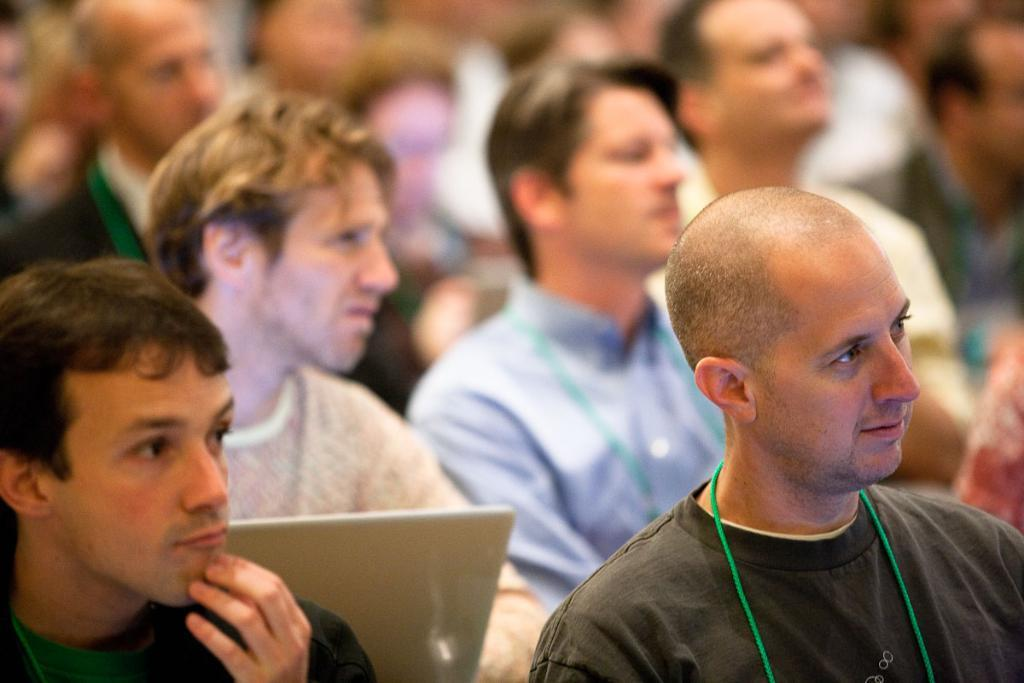What is the main subject of the image? The main subject of the image is a group of men. What are the men in the image doing? The men are looking to the right side. Can you describe the man on the left side of the image? There is a man holding a laptop on the left side of the image. What type of wheel can be seen in the image? There is no wheel present in the image. Is there an umbrella visible in the image? No, there is no umbrella visible in the image. 